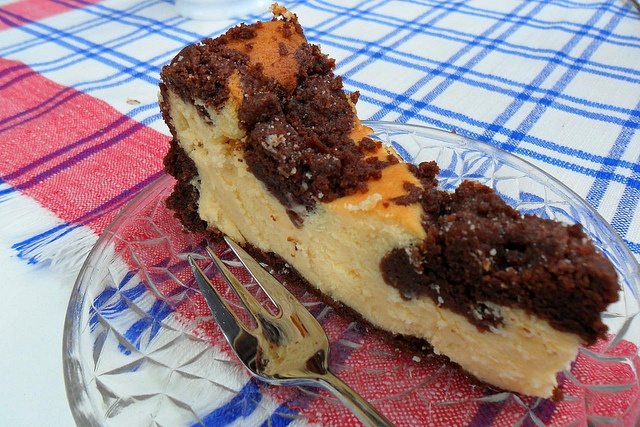Describe the objects in this image and their specific colors. I can see dining table in lightgray, black, maroon, tan, and brown tones, cake in lightblue, black, tan, maroon, and gray tones, and fork in lightblue, olive, black, and gray tones in this image. 